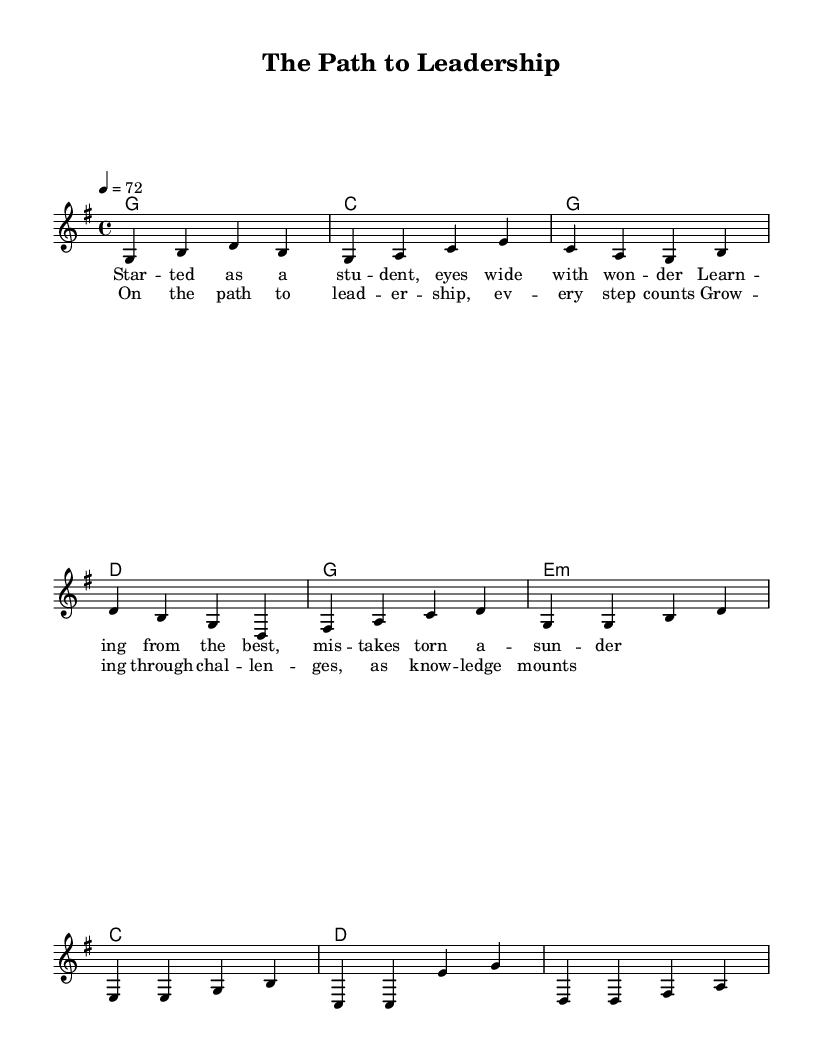What is the key signature of this music? The key signature is indicated at the beginning of the staff, which shows one sharp, corresponding to G major.
Answer: G major What is the time signature of this music? The time signature is written at the beginning of the piece; it indicates there are four beats per measure, as represented by the "4/4" printed in the sheet music.
Answer: 4/4 What is the tempo marking for this piece? The tempo is found at the beginning, where it states "4 = 72," indicating a quarter note is played at a speed of 72 beats per minute.
Answer: 72 How many measures are in the verse section? By counting the bars labeled in the verse section of the melody, there are four measures present.
Answer: 4 What is the first lyric line of the verse? The first lyric line is explicitly provided under the melody notes, which states "Started as a student, eyes wide with wonder."
Answer: Started as a student, eyes wide with wonder What chord follows the first measure of the chorus? In the chord progression, the chord that follows the first measure of the chorus is E minor, as indicated in the harmonies section of the music.
Answer: E minor What theme is explored in this song? The lyrics indicate a journey focused on growth and challenges inherent in developing leadership qualities, exploring the reflective nature of personal development through the metaphors used.
Answer: Leadership journey 